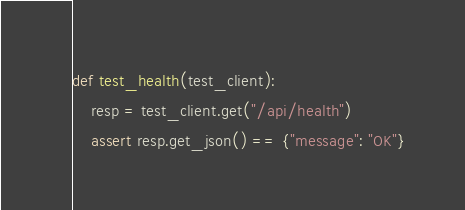<code> <loc_0><loc_0><loc_500><loc_500><_Python_>def test_health(test_client):
    resp = test_client.get("/api/health")
    assert resp.get_json() == {"message": "OK"}
</code> 